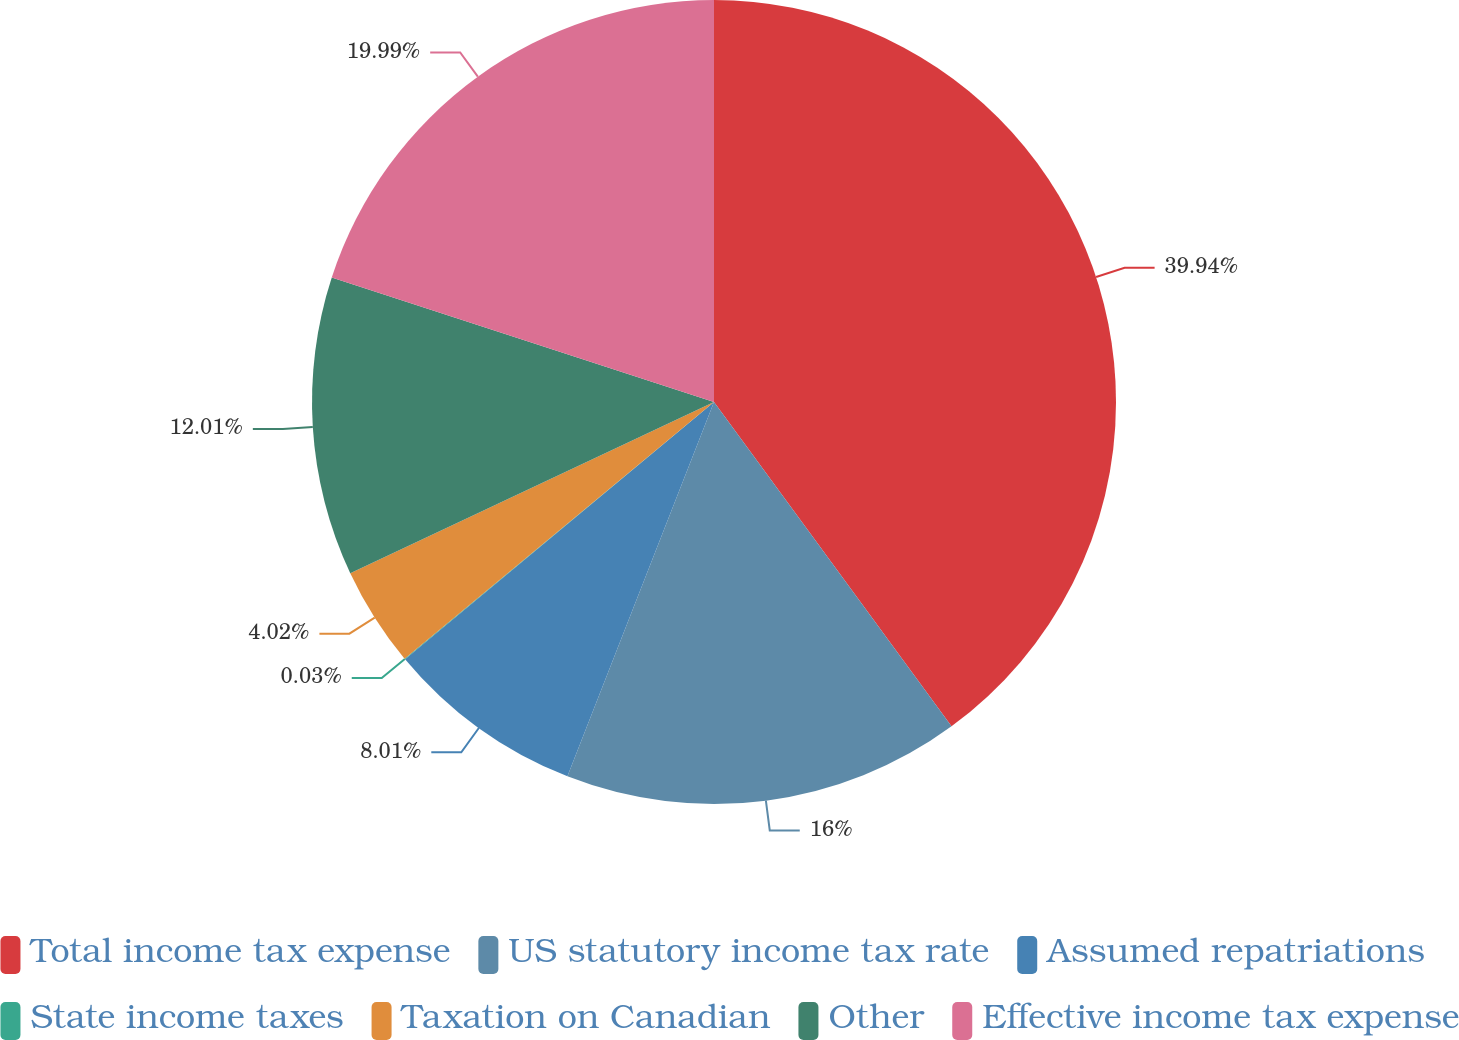Convert chart. <chart><loc_0><loc_0><loc_500><loc_500><pie_chart><fcel>Total income tax expense<fcel>US statutory income tax rate<fcel>Assumed repatriations<fcel>State income taxes<fcel>Taxation on Canadian<fcel>Other<fcel>Effective income tax expense<nl><fcel>39.94%<fcel>16.0%<fcel>8.01%<fcel>0.03%<fcel>4.02%<fcel>12.01%<fcel>19.99%<nl></chart> 